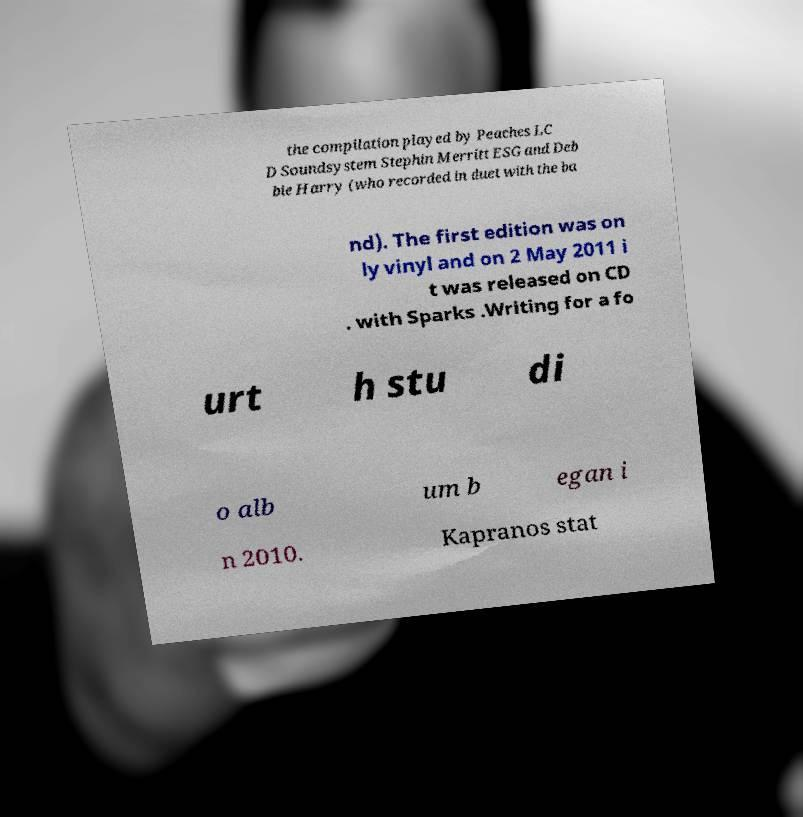There's text embedded in this image that I need extracted. Can you transcribe it verbatim? the compilation played by Peaches LC D Soundsystem Stephin Merritt ESG and Deb bie Harry (who recorded in duet with the ba nd). The first edition was on ly vinyl and on 2 May 2011 i t was released on CD . with Sparks .Writing for a fo urt h stu di o alb um b egan i n 2010. Kapranos stat 